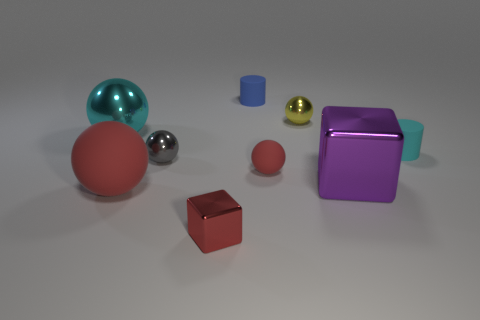How many red spheres must be subtracted to get 1 red spheres? 1 Subtract all cyan blocks. How many red balls are left? 2 Subtract all tiny gray balls. How many balls are left? 4 Add 1 purple blocks. How many objects exist? 10 Subtract all red balls. How many balls are left? 3 Subtract 1 spheres. How many spheres are left? 4 Subtract all cylinders. How many objects are left? 7 Subtract all purple balls. Subtract all red blocks. How many balls are left? 5 Add 5 red matte cylinders. How many red matte cylinders exist? 5 Subtract 0 brown spheres. How many objects are left? 9 